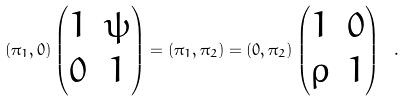Convert formula to latex. <formula><loc_0><loc_0><loc_500><loc_500>( \pi _ { 1 } , 0 ) \begin{pmatrix} 1 & \psi \\ 0 & 1 \end{pmatrix} = ( \pi _ { 1 } , \pi _ { 2 } ) = ( 0 , \pi _ { 2 } ) \begin{pmatrix} 1 & 0 \\ \rho & 1 \end{pmatrix} \ .</formula> 